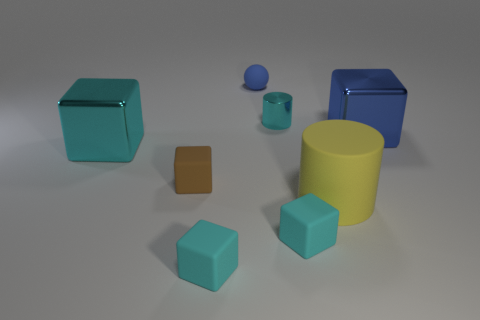How many cyan cubes must be subtracted to get 1 cyan cubes? 2 Subtract all blue metal cubes. How many cubes are left? 4 Add 2 tiny rubber objects. How many objects exist? 10 Subtract all balls. How many objects are left? 7 Subtract 1 blocks. How many blocks are left? 4 Subtract all yellow cylinders. How many cylinders are left? 1 Subtract all red cylinders. How many cyan blocks are left? 3 Add 5 cyan blocks. How many cyan blocks are left? 8 Add 3 yellow metallic blocks. How many yellow metallic blocks exist? 3 Subtract 0 purple cylinders. How many objects are left? 8 